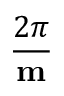<formula> <loc_0><loc_0><loc_500><loc_500>\frac { 2 \pi } { m }</formula> 